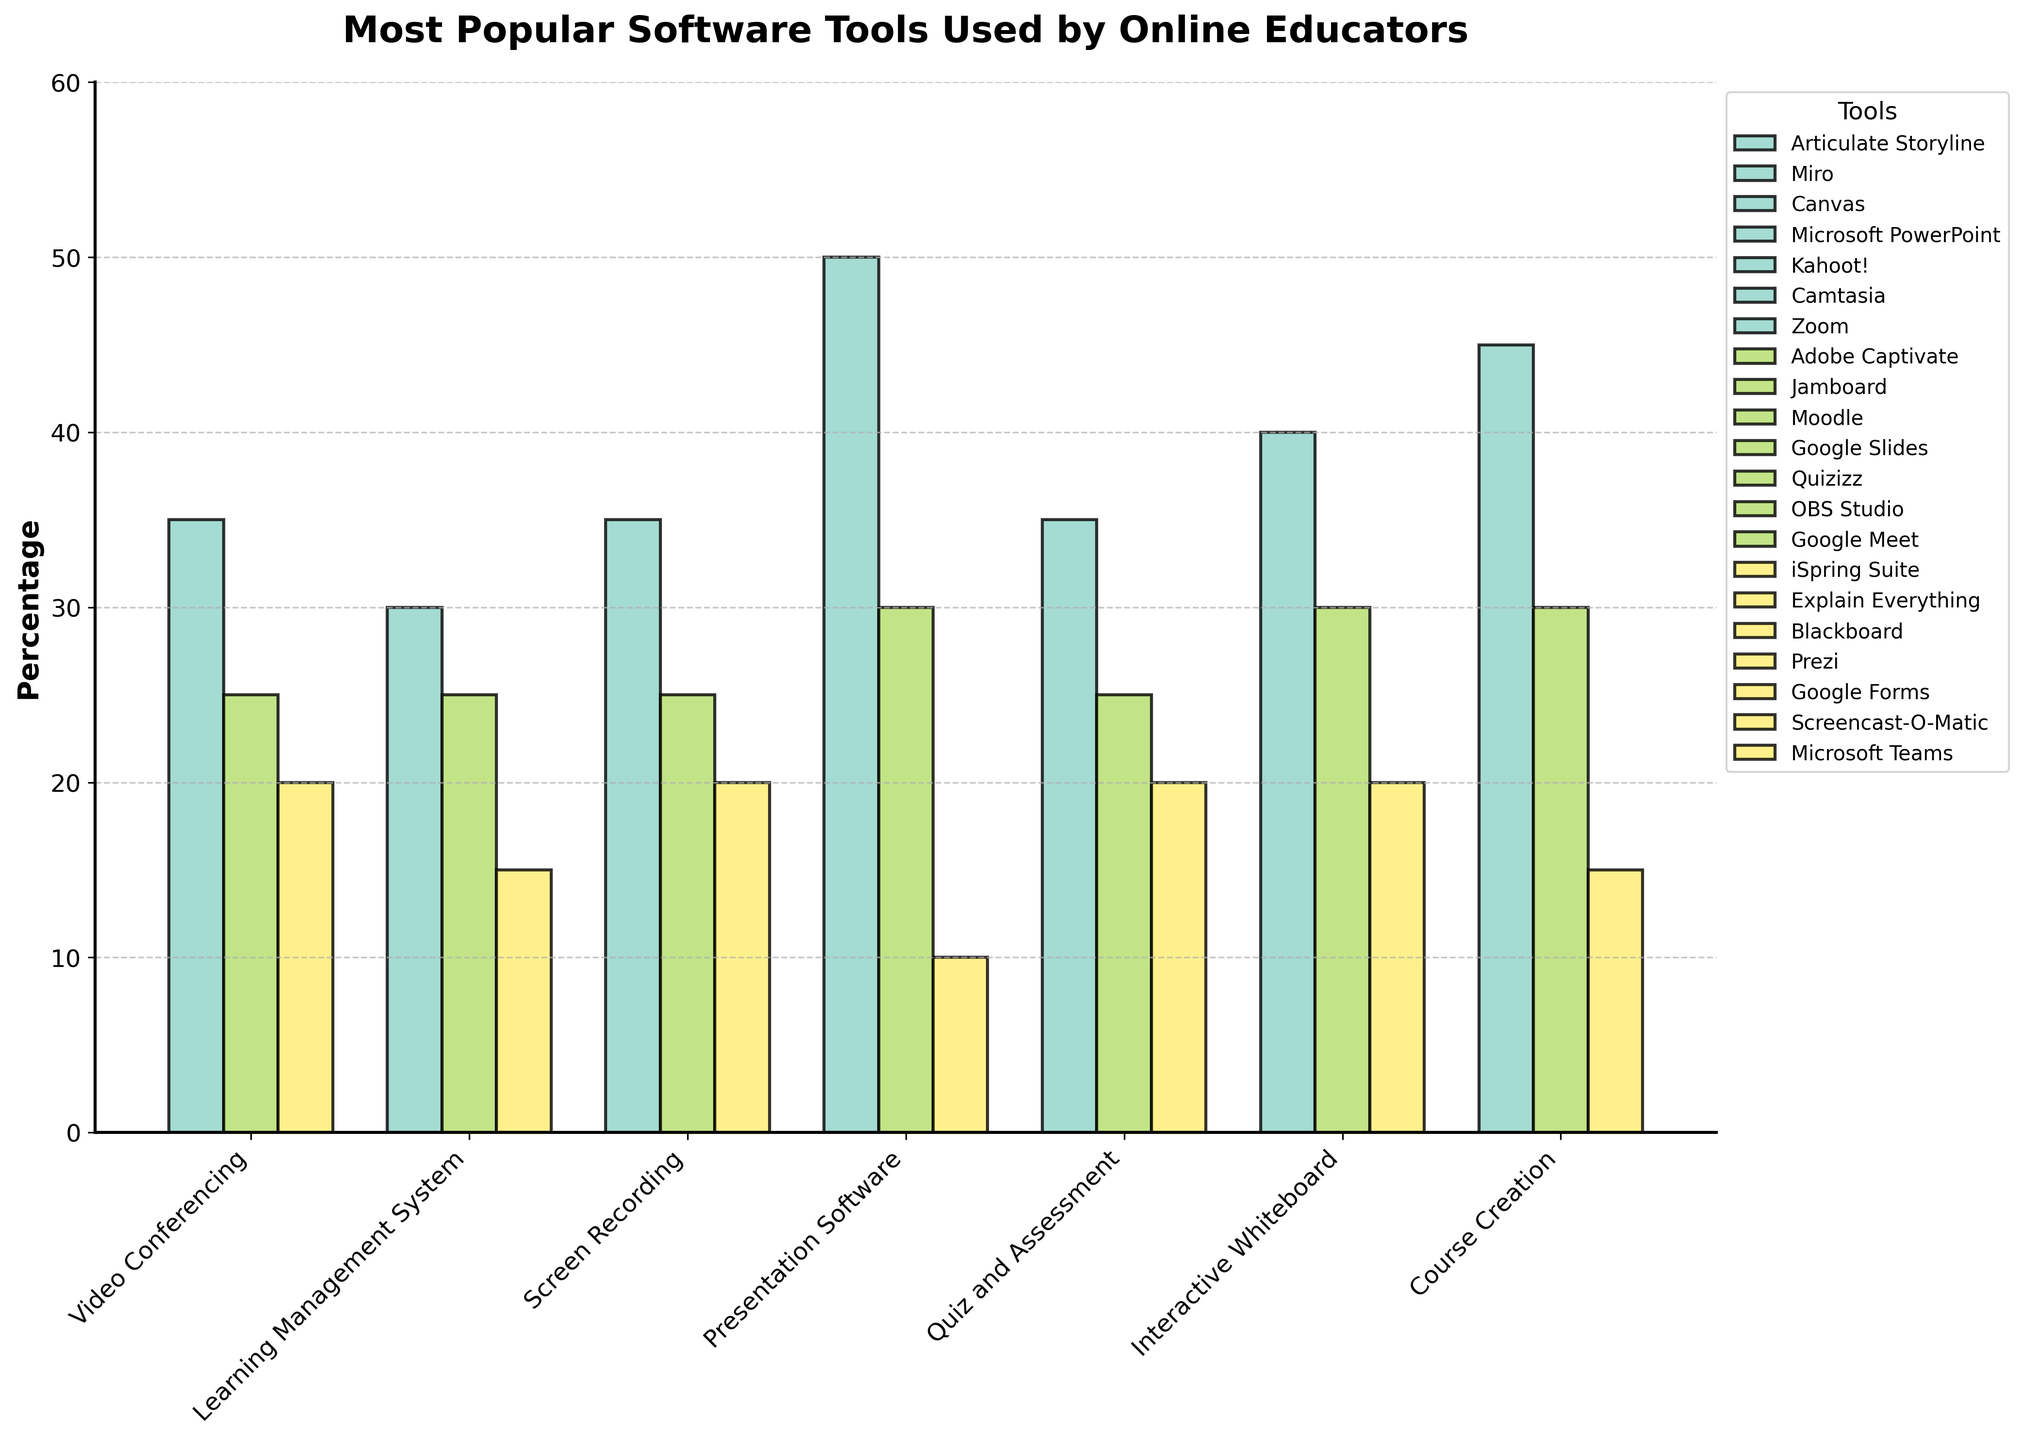What is the most popular video conferencing tool among online educators? The tallest bar in the "Video Conferencing" category represents the most popular tool. Zoom is highest at 45%.
Answer: Zoom Which Learning Management System tool has the lowest usage percentage? In the "Learning Management System" category, the shortest bar indicates the lowest usage. Blackboard is the lowest at 20%.
Answer: Blackboard Between Microsoft PowerPoint and Prezi, which is more popular and by how much? Microsoft PowerPoint has a height corresponding to 50%, while Prezi is at 10%. The difference between their percentages is 50% - 10% = 40%.
Answer: Microsoft PowerPoint, by 40% What is the combined percentage of users for Kahoot! and Google Forms in the Quiz and Assessment category? Identifying the heights of Kahoot! and Google Forms bars in the "Quiz and Assessment" category gives 35% and 20%. The total sum is 35% + 20% = 55%.
Answer: 55% Is the usage percentage of OBS Studio in the Screen Recording category higher than Google Meet in the Video Conferencing category? The bar for OBS Studio in "Screen Recording" is at 30%, and Google Meet in "Video Conferencing" is also at 30%. OBS Studio is not higher than Google Meet.
Answer: No Which category has the widest variation in tool usage percentages? We compare the range within each category by subtracting the smallest percentage from the largest in each category. Here, comparing each: Video Conferencing (45% - 15% = 30%), Learning Management System (35% - 20% = 15%), Screen Recording (40% - 20% = 20%), Presentation Software (50% - 10% = 40%), Quiz and Assessment (35% - 20% = 15%), Interactive Whiteboard (30% - 15% = 15%), and Course Creation (35% - 20% = 15%). The widest range is in "Presentation Software" with 40%.
Answer: Presentation Software How much more popular is Camtasia compared to Screencast-O-Matic in the Screen Recording category? Camtasia is at 40% and Screencast-O-Matic is at 20% in Screen Recording. The difference is 40% - 20% = 20%.
Answer: 20% Which interactive whiteboard tool has a higher usage percentage than Explain Everything, but lower than Miro? In the "Interactive Whiteboard" category, Jamboard has 25%, which is higher than Explain Everything's 15%, but lower than Miro's 30%.
Answer: Jamboard Identify the categories where the tool with the highest usage percentage surpasses 40%. The categories to check for the highest bar exceeding 40% are Video Conferencing (Zoom at 45%) and Presentation Software (Microsoft PowerPoint at 50%). Both surpass 40%.
Answer: Video Conferencing and Presentation Software 